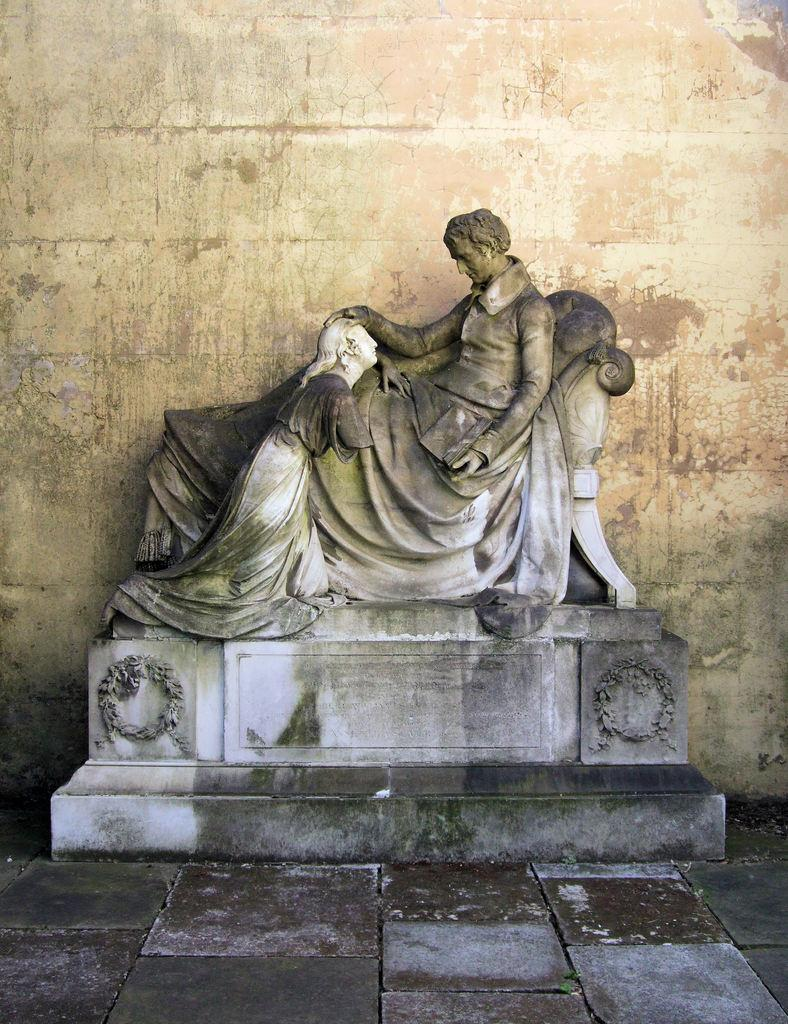What is the main subject in the image? There is a statue in the image. What else can be seen in the image besides the statue? There is a wall visible in the image, specifically on the backside of the statue. What type of magic is the statue performing in the image? There is no indication of magic or any magical activity in the image; it simply features a statue and a wall. 